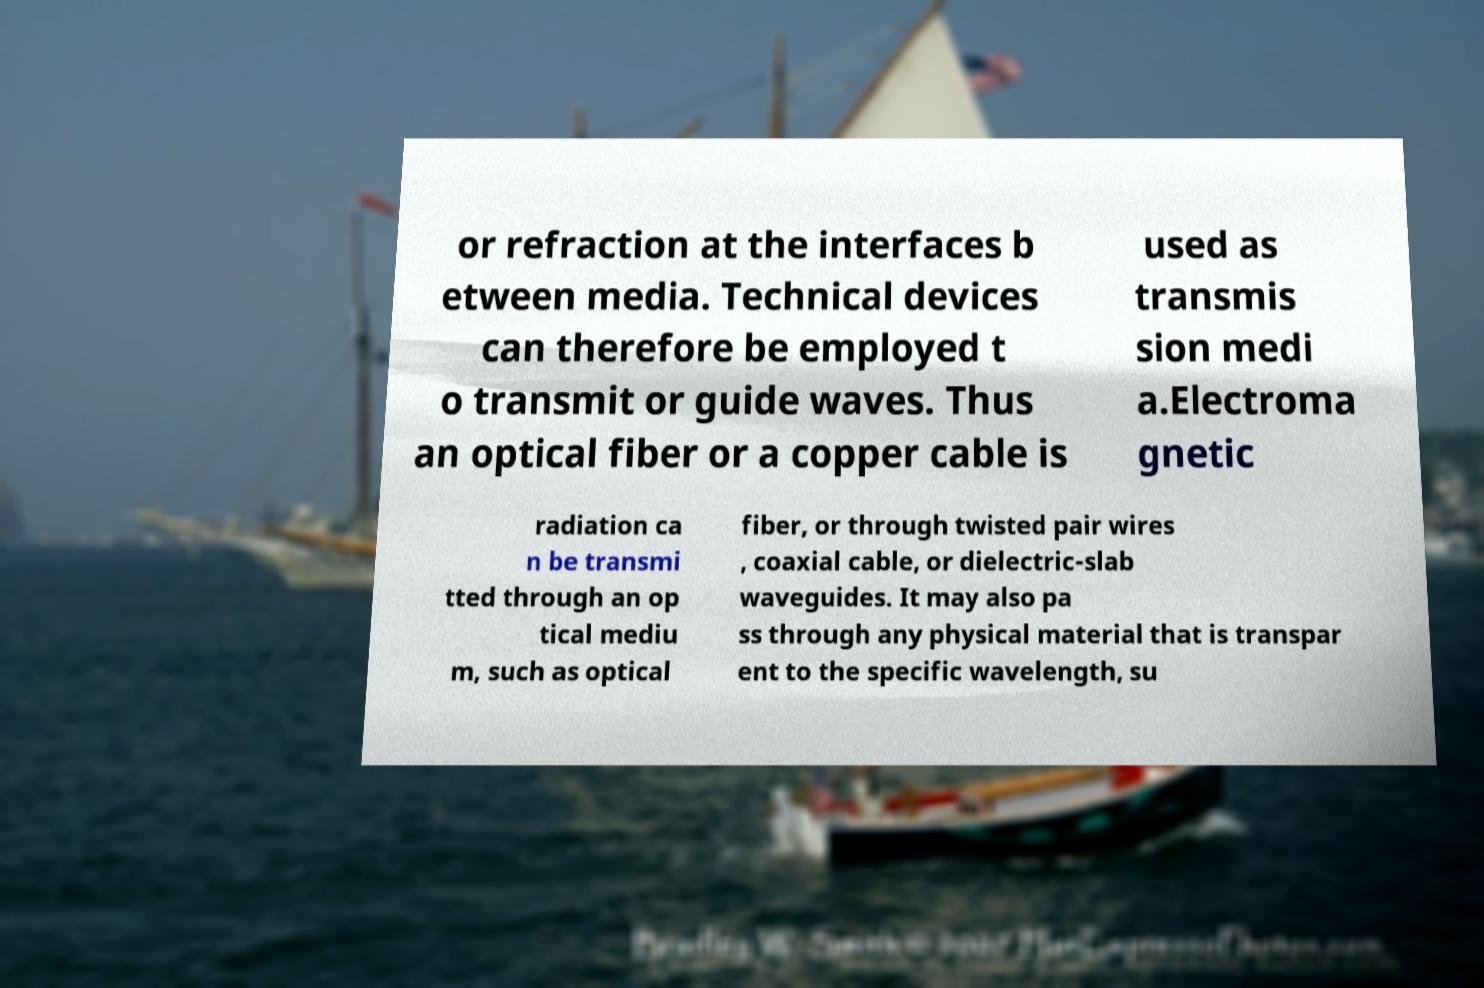Could you extract and type out the text from this image? or refraction at the interfaces b etween media. Technical devices can therefore be employed t o transmit or guide waves. Thus an optical fiber or a copper cable is used as transmis sion medi a.Electroma gnetic radiation ca n be transmi tted through an op tical mediu m, such as optical fiber, or through twisted pair wires , coaxial cable, or dielectric-slab waveguides. It may also pa ss through any physical material that is transpar ent to the specific wavelength, su 